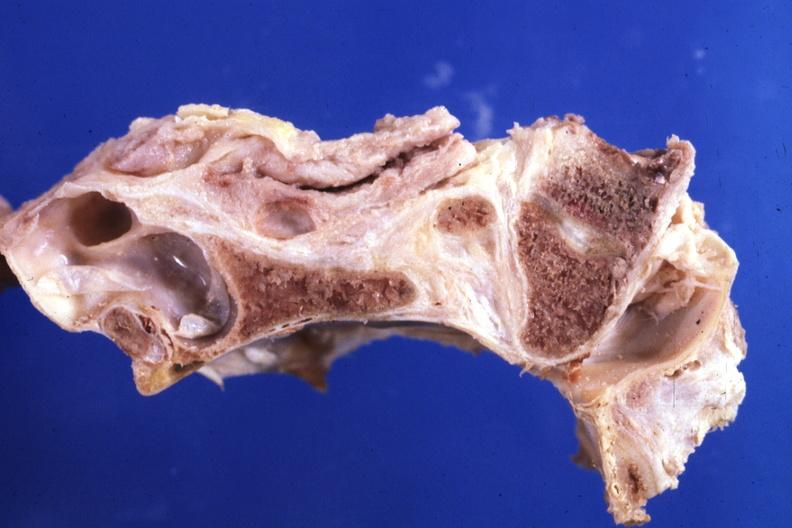does this image show fixed tissue saggital section stenotic foramen magnum?
Answer the question using a single word or phrase. Yes 